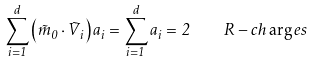Convert formula to latex. <formula><loc_0><loc_0><loc_500><loc_500>\sum _ { i = 1 } ^ { d } \left ( \vec { m } _ { 0 } \cdot \vec { V } _ { i } \right ) a _ { i } = \sum _ { i = 1 } ^ { d } a _ { i } = 2 \quad R - c h \arg e s</formula> 